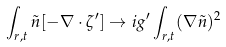<formula> <loc_0><loc_0><loc_500><loc_500>\int _ { { r } , t } \tilde { n } [ - \nabla \cdot \zeta ^ { \prime } ] \rightarrow i g ^ { \prime } \int _ { { r } , t } ( \nabla \tilde { n } ) ^ { 2 }</formula> 